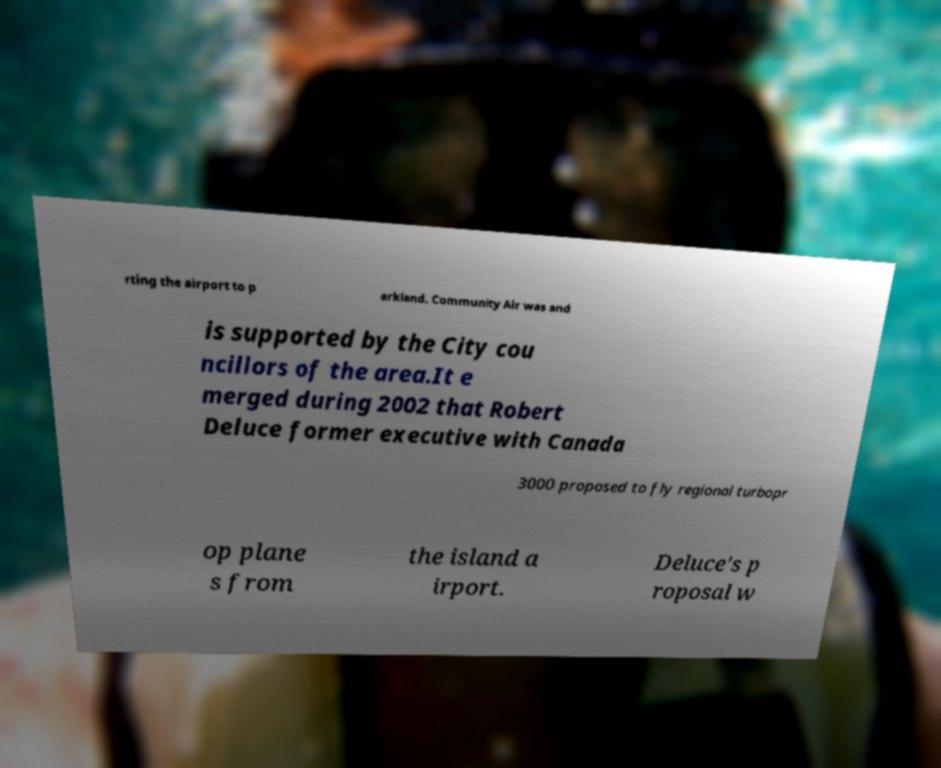Please identify and transcribe the text found in this image. rting the airport to p arkland. Community Air was and is supported by the City cou ncillors of the area.It e merged during 2002 that Robert Deluce former executive with Canada 3000 proposed to fly regional turbopr op plane s from the island a irport. Deluce's p roposal w 